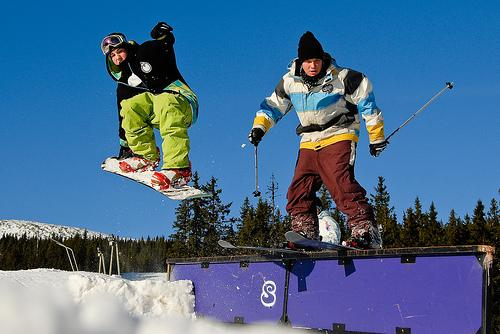Which objects in this image are airborne? An airborne person riding a snowboard and the snowboard in mid-air are airborne objects in this image. How many people are there doing snow sports in the image? There are two people doing snow sports, one skiing and one snowboarding. Briefly describe the background elements in this image. The background features a clear blue sky, a snow-covered hill, a mound of white snow, and conifer trees in the scene. What is the unique design on the purple platform? There is a white "S" spray-painted on the purple background. What kind of sport or activity dominates this image? Snow sports such as skiing and snowboarding dominate this image. What location does this image seem to take place in? The image seems to take place at a snow-covered location, possibly a ski resort or mountain. Can you describe the clothing and accessories of the person snowboarding? The snowboarder is wearing lime green pants, a black jacket with a white patch on the chest, and protective safety goggles. List three safety gear or accessories visible in the image. A pair of protective eyewear (snow goggles), a black beanie hat, and red and grey ski boots are safety gear or accessories visible in the image. What is the main action happening in this image between the skier and the snowboarder? The main action is both the skier and snowboarder jumping over a purple ramp. Identify the color of pants worn by the snowboarder. The snowboarder is wearing lime green pants. 